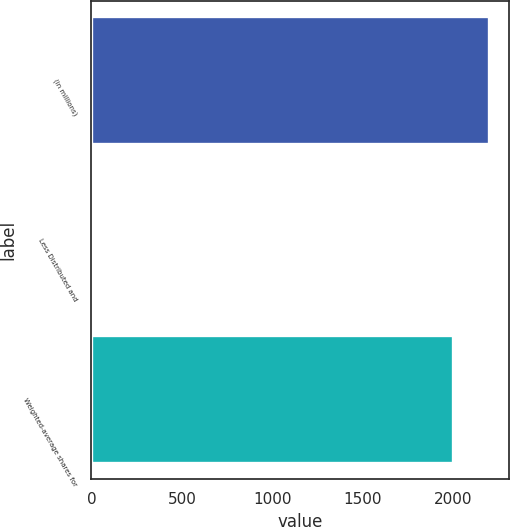Convert chart to OTSL. <chart><loc_0><loc_0><loc_500><loc_500><bar_chart><fcel>(in millions)<fcel>Less Distributed and<fcel>Weighted-average shares for<nl><fcel>2199.1<fcel>12<fcel>1999<nl></chart> 